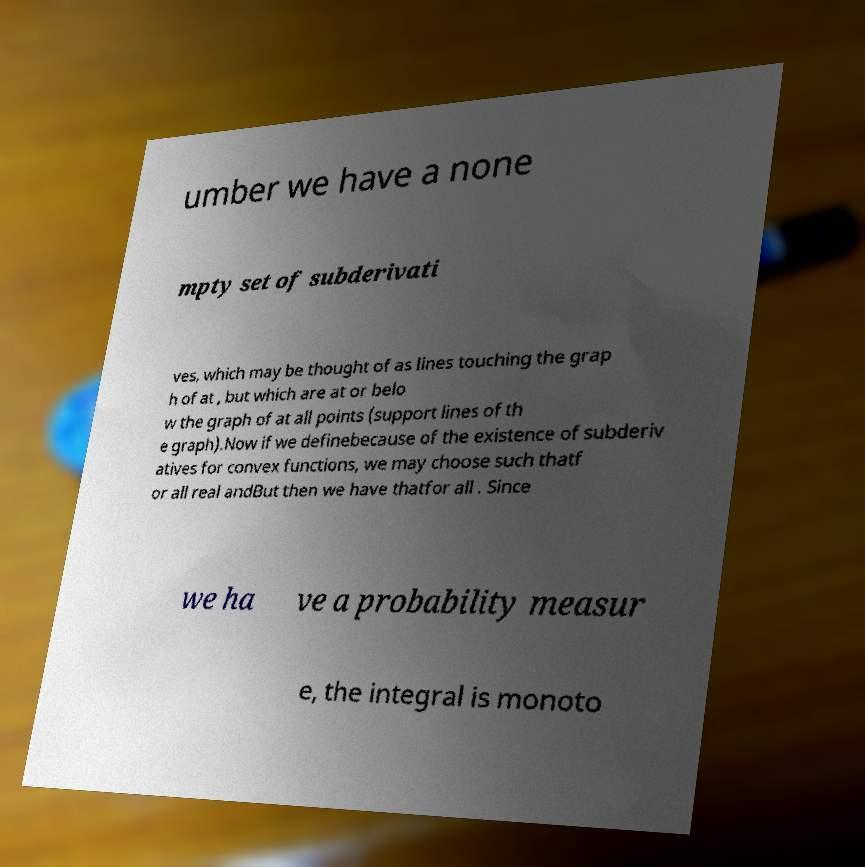There's text embedded in this image that I need extracted. Can you transcribe it verbatim? umber we have a none mpty set of subderivati ves, which may be thought of as lines touching the grap h of at , but which are at or belo w the graph of at all points (support lines of th e graph).Now if we definebecause of the existence of subderiv atives for convex functions, we may choose such thatf or all real andBut then we have thatfor all . Since we ha ve a probability measur e, the integral is monoto 